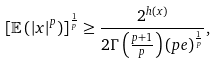Convert formula to latex. <formula><loc_0><loc_0><loc_500><loc_500>\left [ \mathbb { E } \left ( \left | x \right | ^ { p } \right ) \right ] ^ { \frac { 1 } { p } } \geq \frac { 2 ^ { h \left ( x \right ) } } { 2 \Gamma \left ( \frac { p + 1 } { p } \right ) \left ( p e \right ) ^ { \frac { 1 } { p } } } ,</formula> 